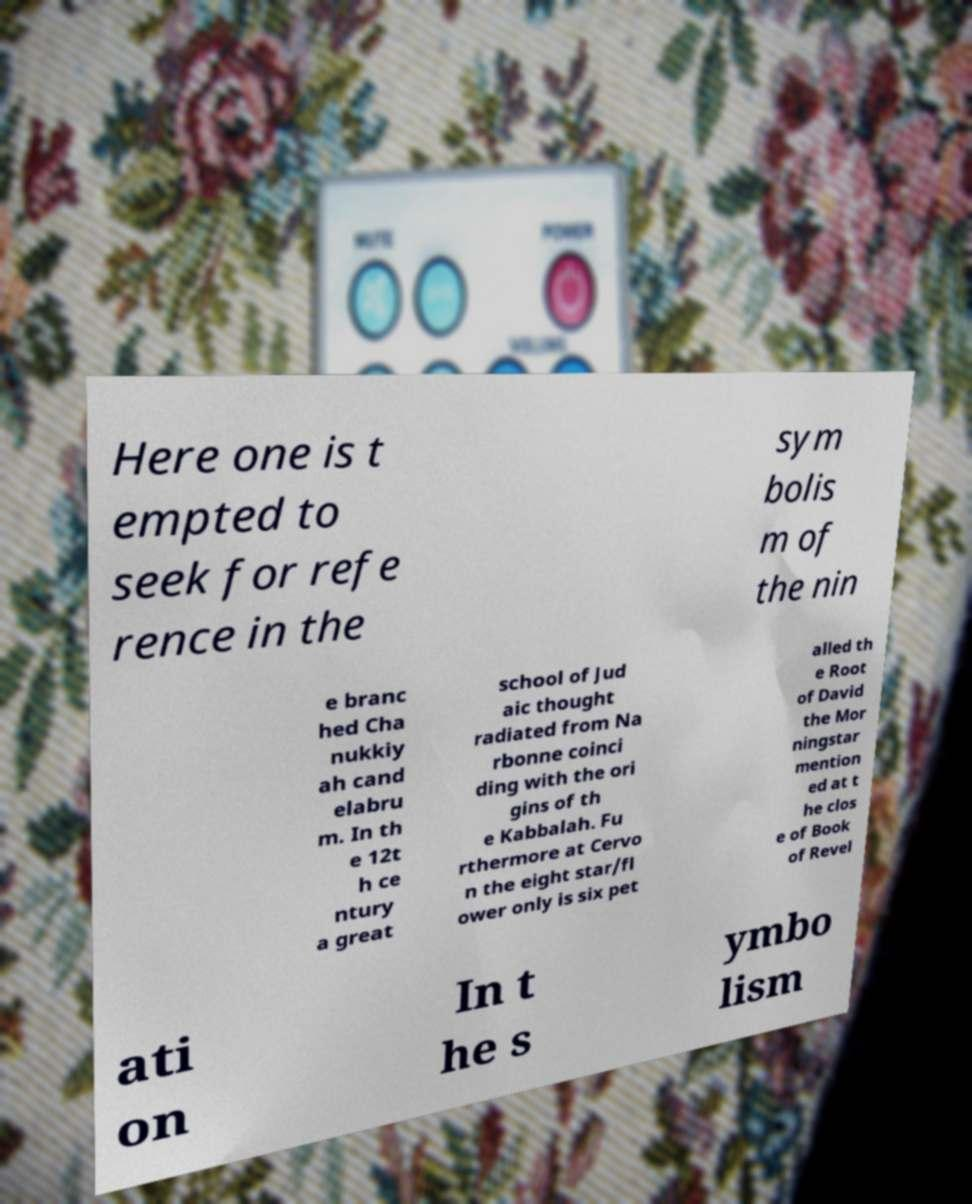Can you accurately transcribe the text from the provided image for me? Here one is t empted to seek for refe rence in the sym bolis m of the nin e branc hed Cha nukkiy ah cand elabru m. In th e 12t h ce ntury a great school of Jud aic thought radiated from Na rbonne coinci ding with the ori gins of th e Kabbalah. Fu rthermore at Cervo n the eight star/fl ower only is six pet alled th e Root of David the Mor ningstar mention ed at t he clos e of Book of Revel ati on In t he s ymbo lism 